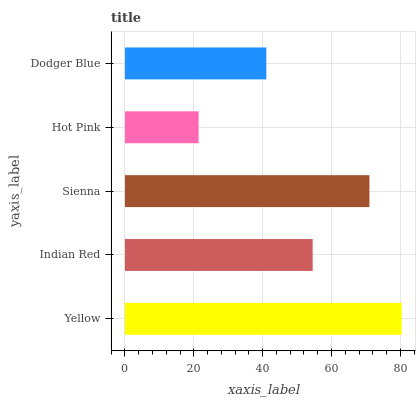Is Hot Pink the minimum?
Answer yes or no. Yes. Is Yellow the maximum?
Answer yes or no. Yes. Is Indian Red the minimum?
Answer yes or no. No. Is Indian Red the maximum?
Answer yes or no. No. Is Yellow greater than Indian Red?
Answer yes or no. Yes. Is Indian Red less than Yellow?
Answer yes or no. Yes. Is Indian Red greater than Yellow?
Answer yes or no. No. Is Yellow less than Indian Red?
Answer yes or no. No. Is Indian Red the high median?
Answer yes or no. Yes. Is Indian Red the low median?
Answer yes or no. Yes. Is Sienna the high median?
Answer yes or no. No. Is Dodger Blue the low median?
Answer yes or no. No. 